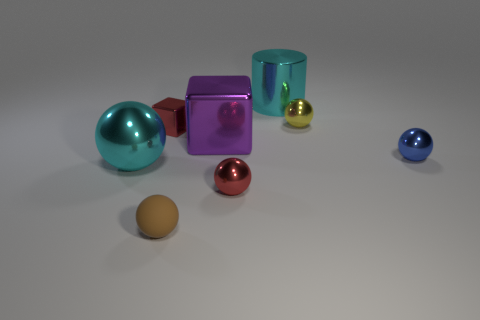Subtract all brown spheres. How many spheres are left? 4 Subtract all green cylinders. Subtract all green cubes. How many cylinders are left? 1 Add 1 big balls. How many objects exist? 9 Subtract all cubes. How many objects are left? 6 Add 6 small yellow things. How many small yellow things are left? 7 Add 5 brown blocks. How many brown blocks exist? 5 Subtract 0 cyan blocks. How many objects are left? 8 Subtract all cyan cylinders. Subtract all large shiny objects. How many objects are left? 4 